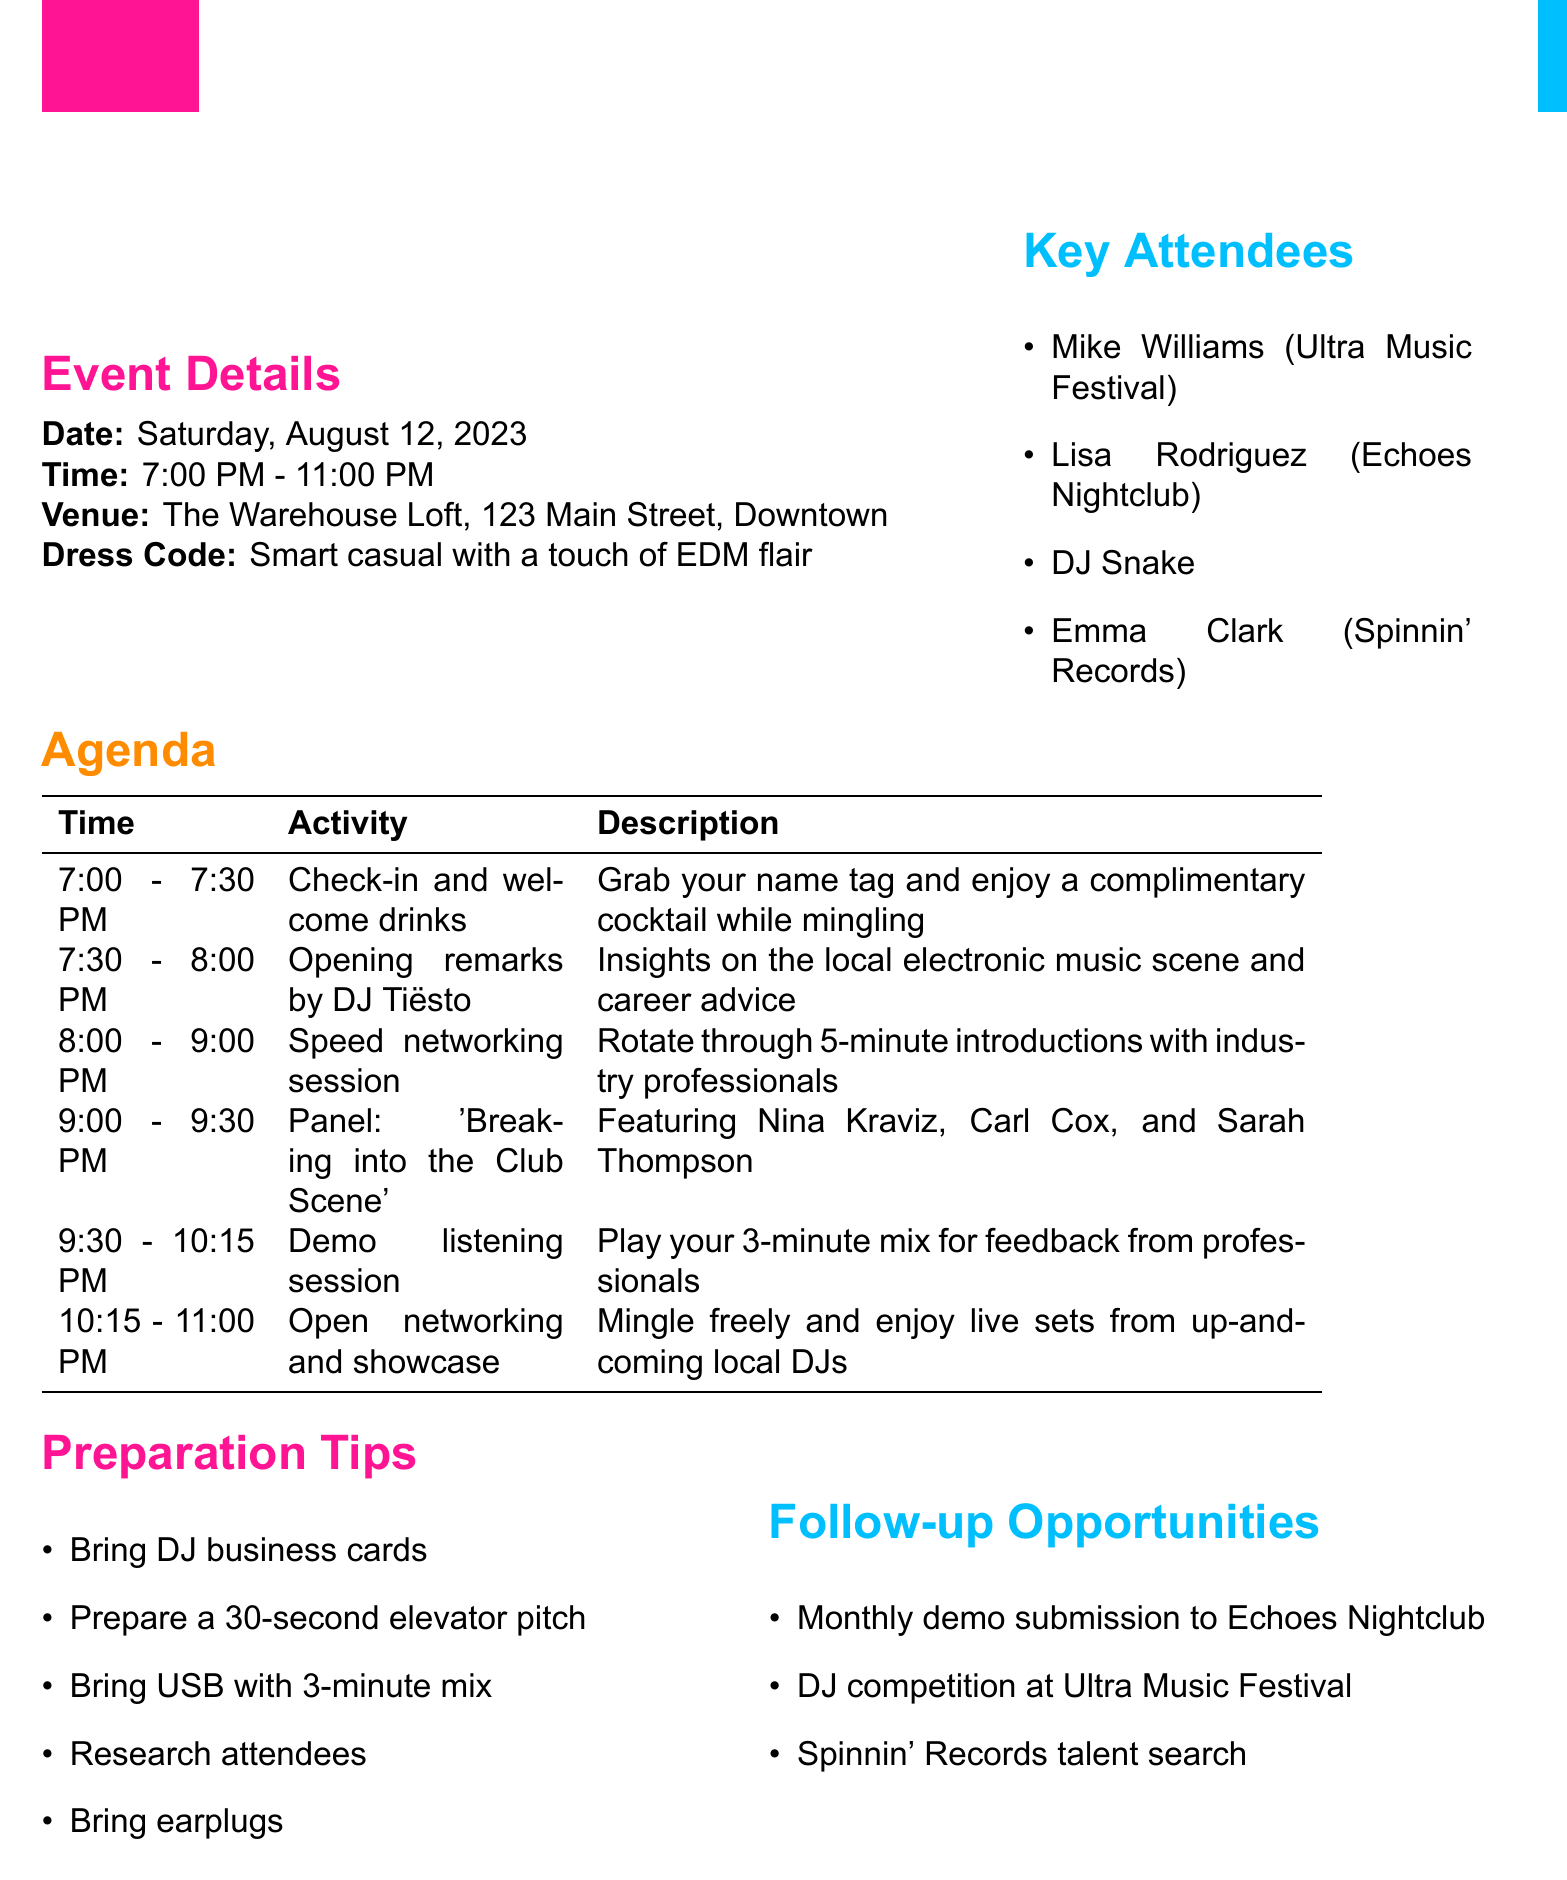what is the name of the event? The name of the event is explicitly mentioned as "Beat Connect: DJ Networking Mixer".
Answer: Beat Connect: DJ Networking Mixer what is the date of the event? The date of the event is clearly provided in the document as "Saturday, August 12, 2023".
Answer: Saturday, August 12, 2023 who will give the opening remarks? The document states that the event host DJ Tiësto will give the opening remarks.
Answer: DJ Tiësto what is the time for the demo listening session? The time for the demo listening session is given as "9:30 PM - 10:15 PM" in the agenda.
Answer: 9:30 PM - 10:15 PM which club owner is featured in the panel discussion? Sarah Thompson is identified as the local club owner featured in the panel discussion.
Answer: Sarah Thompson how long is the speed networking session? The speed networking session is outlined to last for "1 hour" based on the agenda timings.
Answer: 1 hour what is one of the preparation tips? The document lists several preparation tips, one of which is to "Bring business cards with your DJ name and contact information".
Answer: Bring business cards with your DJ name and contact information what is an opportunity for follow-up after the event? The document mentions "Monthly demo submission to Echoes Nightclub" as a follow-up opportunity.
Answer: Monthly demo submission to Echoes Nightclub who are some of the key attendees? Several key attendees are mentioned, including Mike Williams, Lisa Rodriguez, DJ Snake, and Emma Clark.
Answer: Mike Williams, Lisa Rodriguez, DJ Snake, and Emma Clark 